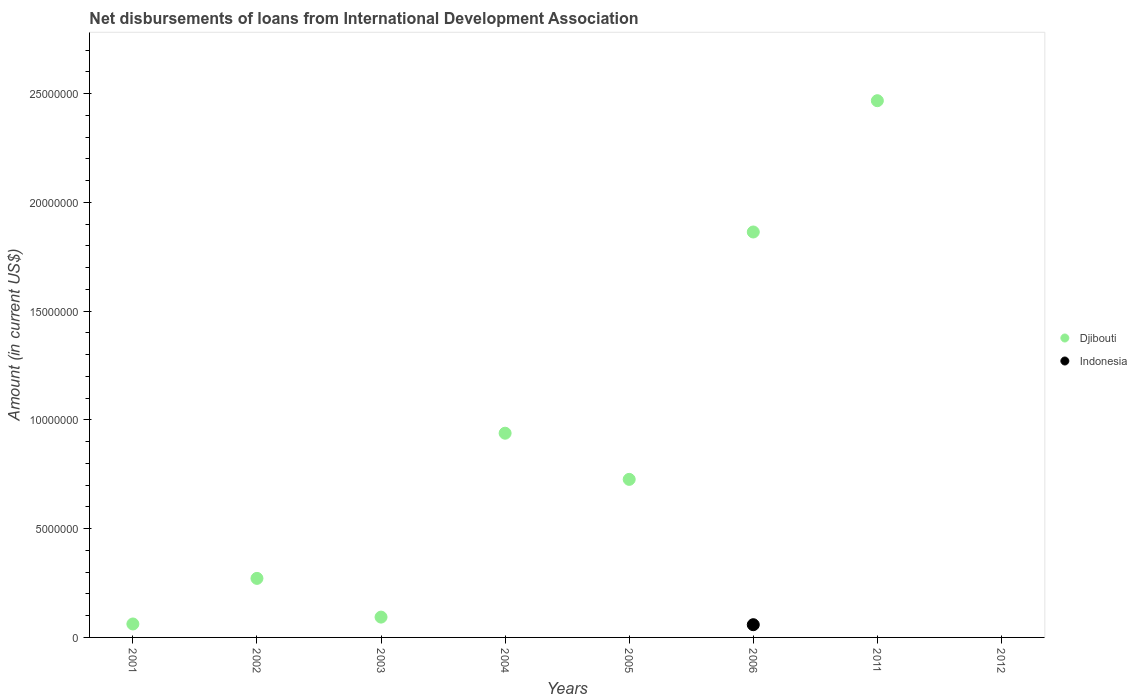What is the amount of loans disbursed in Djibouti in 2001?
Offer a very short reply. 6.18e+05. Across all years, what is the maximum amount of loans disbursed in Djibouti?
Provide a succinct answer. 2.47e+07. Across all years, what is the minimum amount of loans disbursed in Djibouti?
Your response must be concise. 0. In which year was the amount of loans disbursed in Indonesia maximum?
Make the answer very short. 2006. What is the total amount of loans disbursed in Indonesia in the graph?
Provide a short and direct response. 5.85e+05. What is the difference between the amount of loans disbursed in Djibouti in 2001 and that in 2004?
Make the answer very short. -8.77e+06. What is the difference between the amount of loans disbursed in Indonesia in 2006 and the amount of loans disbursed in Djibouti in 2011?
Give a very brief answer. -2.41e+07. What is the average amount of loans disbursed in Djibouti per year?
Keep it short and to the point. 8.03e+06. In how many years, is the amount of loans disbursed in Djibouti greater than 3000000 US$?
Ensure brevity in your answer.  4. What is the ratio of the amount of loans disbursed in Djibouti in 2003 to that in 2004?
Your answer should be compact. 0.1. Is the amount of loans disbursed in Djibouti in 2006 less than that in 2011?
Provide a short and direct response. Yes. What is the difference between the highest and the second highest amount of loans disbursed in Djibouti?
Your response must be concise. 6.04e+06. What is the difference between the highest and the lowest amount of loans disbursed in Indonesia?
Your answer should be very brief. 5.85e+05. Is the sum of the amount of loans disbursed in Djibouti in 2005 and 2011 greater than the maximum amount of loans disbursed in Indonesia across all years?
Ensure brevity in your answer.  Yes. Is the amount of loans disbursed in Indonesia strictly greater than the amount of loans disbursed in Djibouti over the years?
Your answer should be very brief. No. Is the amount of loans disbursed in Indonesia strictly less than the amount of loans disbursed in Djibouti over the years?
Your answer should be very brief. Yes. How many years are there in the graph?
Your answer should be compact. 8. Does the graph contain grids?
Your answer should be very brief. No. How many legend labels are there?
Make the answer very short. 2. How are the legend labels stacked?
Provide a short and direct response. Vertical. What is the title of the graph?
Your answer should be compact. Net disbursements of loans from International Development Association. What is the label or title of the Y-axis?
Ensure brevity in your answer.  Amount (in current US$). What is the Amount (in current US$) of Djibouti in 2001?
Ensure brevity in your answer.  6.18e+05. What is the Amount (in current US$) of Indonesia in 2001?
Offer a terse response. 0. What is the Amount (in current US$) of Djibouti in 2002?
Your answer should be very brief. 2.71e+06. What is the Amount (in current US$) of Indonesia in 2002?
Your answer should be very brief. 0. What is the Amount (in current US$) of Djibouti in 2003?
Provide a short and direct response. 9.34e+05. What is the Amount (in current US$) in Djibouti in 2004?
Your answer should be compact. 9.39e+06. What is the Amount (in current US$) of Djibouti in 2005?
Ensure brevity in your answer.  7.26e+06. What is the Amount (in current US$) in Indonesia in 2005?
Your response must be concise. 0. What is the Amount (in current US$) of Djibouti in 2006?
Your answer should be very brief. 1.86e+07. What is the Amount (in current US$) of Indonesia in 2006?
Your answer should be compact. 5.85e+05. What is the Amount (in current US$) in Djibouti in 2011?
Your answer should be very brief. 2.47e+07. Across all years, what is the maximum Amount (in current US$) of Djibouti?
Make the answer very short. 2.47e+07. Across all years, what is the maximum Amount (in current US$) of Indonesia?
Keep it short and to the point. 5.85e+05. Across all years, what is the minimum Amount (in current US$) of Djibouti?
Give a very brief answer. 0. What is the total Amount (in current US$) of Djibouti in the graph?
Provide a succinct answer. 6.42e+07. What is the total Amount (in current US$) of Indonesia in the graph?
Your answer should be compact. 5.85e+05. What is the difference between the Amount (in current US$) in Djibouti in 2001 and that in 2002?
Keep it short and to the point. -2.10e+06. What is the difference between the Amount (in current US$) in Djibouti in 2001 and that in 2003?
Make the answer very short. -3.16e+05. What is the difference between the Amount (in current US$) of Djibouti in 2001 and that in 2004?
Make the answer very short. -8.77e+06. What is the difference between the Amount (in current US$) in Djibouti in 2001 and that in 2005?
Offer a terse response. -6.65e+06. What is the difference between the Amount (in current US$) in Djibouti in 2001 and that in 2006?
Ensure brevity in your answer.  -1.80e+07. What is the difference between the Amount (in current US$) in Djibouti in 2001 and that in 2011?
Make the answer very short. -2.41e+07. What is the difference between the Amount (in current US$) in Djibouti in 2002 and that in 2003?
Keep it short and to the point. 1.78e+06. What is the difference between the Amount (in current US$) of Djibouti in 2002 and that in 2004?
Provide a short and direct response. -6.67e+06. What is the difference between the Amount (in current US$) of Djibouti in 2002 and that in 2005?
Offer a terse response. -4.55e+06. What is the difference between the Amount (in current US$) of Djibouti in 2002 and that in 2006?
Your answer should be compact. -1.59e+07. What is the difference between the Amount (in current US$) in Djibouti in 2002 and that in 2011?
Your response must be concise. -2.20e+07. What is the difference between the Amount (in current US$) of Djibouti in 2003 and that in 2004?
Ensure brevity in your answer.  -8.45e+06. What is the difference between the Amount (in current US$) of Djibouti in 2003 and that in 2005?
Offer a very short reply. -6.33e+06. What is the difference between the Amount (in current US$) in Djibouti in 2003 and that in 2006?
Give a very brief answer. -1.77e+07. What is the difference between the Amount (in current US$) in Djibouti in 2003 and that in 2011?
Offer a very short reply. -2.37e+07. What is the difference between the Amount (in current US$) in Djibouti in 2004 and that in 2005?
Your answer should be compact. 2.12e+06. What is the difference between the Amount (in current US$) of Djibouti in 2004 and that in 2006?
Give a very brief answer. -9.25e+06. What is the difference between the Amount (in current US$) in Djibouti in 2004 and that in 2011?
Ensure brevity in your answer.  -1.53e+07. What is the difference between the Amount (in current US$) of Djibouti in 2005 and that in 2006?
Your response must be concise. -1.14e+07. What is the difference between the Amount (in current US$) of Djibouti in 2005 and that in 2011?
Ensure brevity in your answer.  -1.74e+07. What is the difference between the Amount (in current US$) in Djibouti in 2006 and that in 2011?
Make the answer very short. -6.04e+06. What is the difference between the Amount (in current US$) of Djibouti in 2001 and the Amount (in current US$) of Indonesia in 2006?
Keep it short and to the point. 3.30e+04. What is the difference between the Amount (in current US$) in Djibouti in 2002 and the Amount (in current US$) in Indonesia in 2006?
Ensure brevity in your answer.  2.13e+06. What is the difference between the Amount (in current US$) of Djibouti in 2003 and the Amount (in current US$) of Indonesia in 2006?
Give a very brief answer. 3.49e+05. What is the difference between the Amount (in current US$) in Djibouti in 2004 and the Amount (in current US$) in Indonesia in 2006?
Provide a succinct answer. 8.80e+06. What is the difference between the Amount (in current US$) in Djibouti in 2005 and the Amount (in current US$) in Indonesia in 2006?
Offer a terse response. 6.68e+06. What is the average Amount (in current US$) in Djibouti per year?
Give a very brief answer. 8.03e+06. What is the average Amount (in current US$) in Indonesia per year?
Your answer should be compact. 7.31e+04. In the year 2006, what is the difference between the Amount (in current US$) in Djibouti and Amount (in current US$) in Indonesia?
Your answer should be very brief. 1.81e+07. What is the ratio of the Amount (in current US$) of Djibouti in 2001 to that in 2002?
Your answer should be compact. 0.23. What is the ratio of the Amount (in current US$) of Djibouti in 2001 to that in 2003?
Make the answer very short. 0.66. What is the ratio of the Amount (in current US$) in Djibouti in 2001 to that in 2004?
Provide a short and direct response. 0.07. What is the ratio of the Amount (in current US$) in Djibouti in 2001 to that in 2005?
Keep it short and to the point. 0.09. What is the ratio of the Amount (in current US$) in Djibouti in 2001 to that in 2006?
Ensure brevity in your answer.  0.03. What is the ratio of the Amount (in current US$) of Djibouti in 2001 to that in 2011?
Your response must be concise. 0.03. What is the ratio of the Amount (in current US$) of Djibouti in 2002 to that in 2003?
Your answer should be very brief. 2.91. What is the ratio of the Amount (in current US$) of Djibouti in 2002 to that in 2004?
Your answer should be compact. 0.29. What is the ratio of the Amount (in current US$) in Djibouti in 2002 to that in 2005?
Provide a short and direct response. 0.37. What is the ratio of the Amount (in current US$) of Djibouti in 2002 to that in 2006?
Provide a short and direct response. 0.15. What is the ratio of the Amount (in current US$) of Djibouti in 2002 to that in 2011?
Provide a succinct answer. 0.11. What is the ratio of the Amount (in current US$) in Djibouti in 2003 to that in 2004?
Your answer should be compact. 0.1. What is the ratio of the Amount (in current US$) of Djibouti in 2003 to that in 2005?
Offer a terse response. 0.13. What is the ratio of the Amount (in current US$) in Djibouti in 2003 to that in 2006?
Ensure brevity in your answer.  0.05. What is the ratio of the Amount (in current US$) of Djibouti in 2003 to that in 2011?
Offer a terse response. 0.04. What is the ratio of the Amount (in current US$) of Djibouti in 2004 to that in 2005?
Keep it short and to the point. 1.29. What is the ratio of the Amount (in current US$) in Djibouti in 2004 to that in 2006?
Offer a terse response. 0.5. What is the ratio of the Amount (in current US$) in Djibouti in 2004 to that in 2011?
Offer a terse response. 0.38. What is the ratio of the Amount (in current US$) of Djibouti in 2005 to that in 2006?
Your answer should be very brief. 0.39. What is the ratio of the Amount (in current US$) in Djibouti in 2005 to that in 2011?
Provide a succinct answer. 0.29. What is the ratio of the Amount (in current US$) in Djibouti in 2006 to that in 2011?
Provide a succinct answer. 0.76. What is the difference between the highest and the second highest Amount (in current US$) of Djibouti?
Make the answer very short. 6.04e+06. What is the difference between the highest and the lowest Amount (in current US$) in Djibouti?
Give a very brief answer. 2.47e+07. What is the difference between the highest and the lowest Amount (in current US$) in Indonesia?
Give a very brief answer. 5.85e+05. 